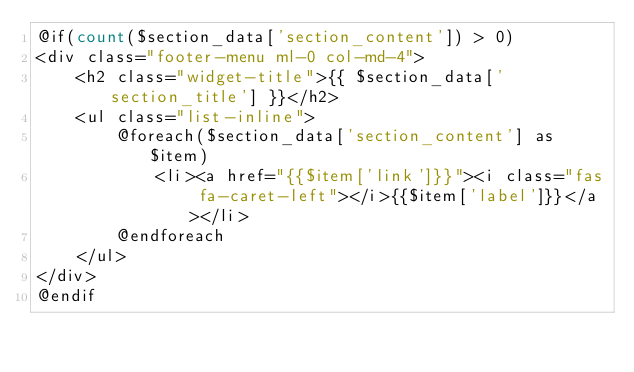<code> <loc_0><loc_0><loc_500><loc_500><_PHP_>@if(count($section_data['section_content']) > 0)
<div class="footer-menu ml-0 col-md-4">
    <h2 class="widget-title">{{ $section_data['section_title'] }}</h2>
    <ul class="list-inline">
        @foreach($section_data['section_content'] as $item)
            <li><a href="{{$item['link']}}"><i class="fas fa-caret-left"></i>{{$item['label']}}</a></li>
        @endforeach
    </ul>
</div>
@endif</code> 